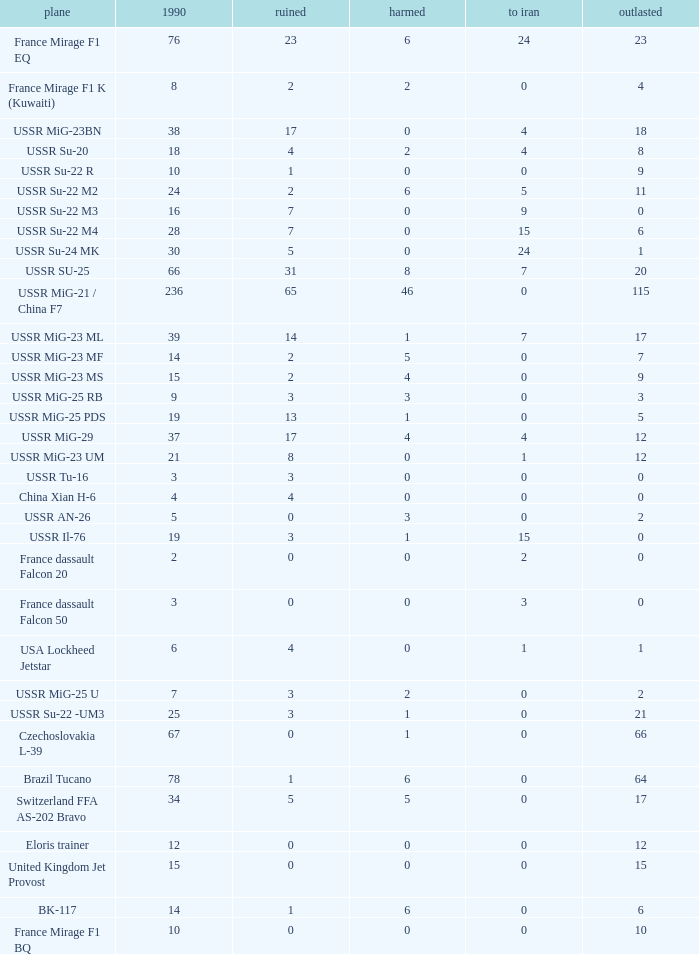If 4 went to iran and the amount that survived was less than 12.0 how many were there in 1990? 1.0. 